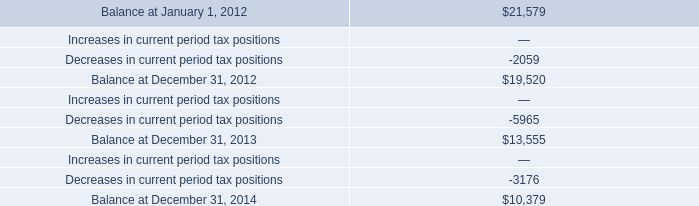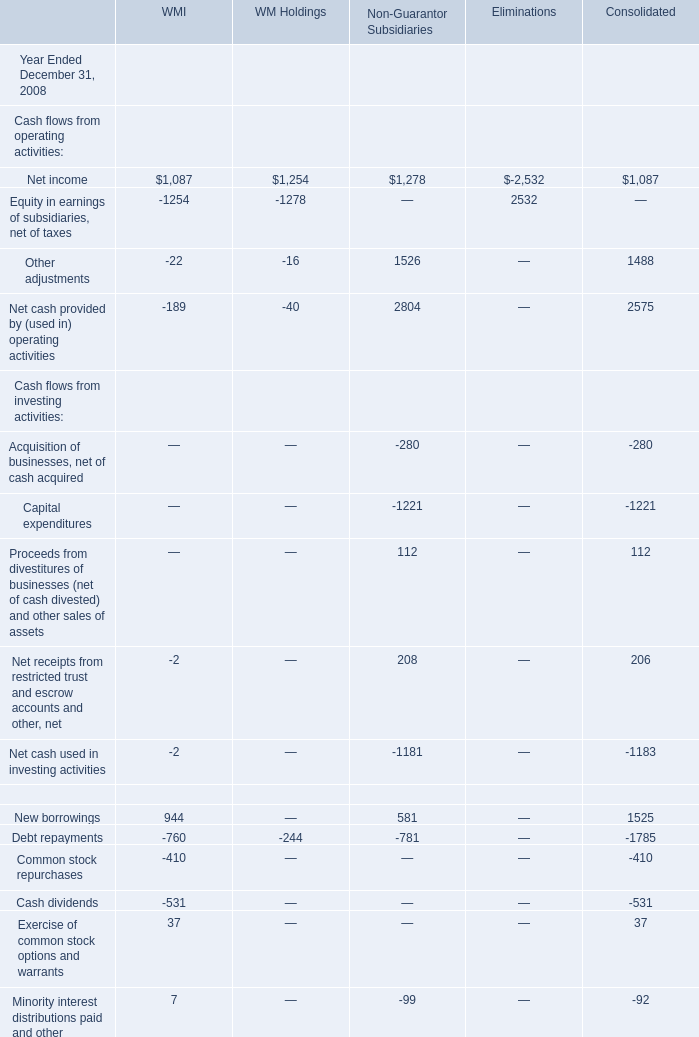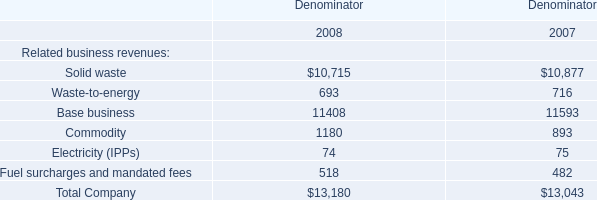What is the average amount of Balance at December 31, 2012, and Equity in earnings of subsidiaries, net of taxes of Eliminations ? 
Computations: ((19520.0 + 2532.0) / 2)
Answer: 11026.0. 